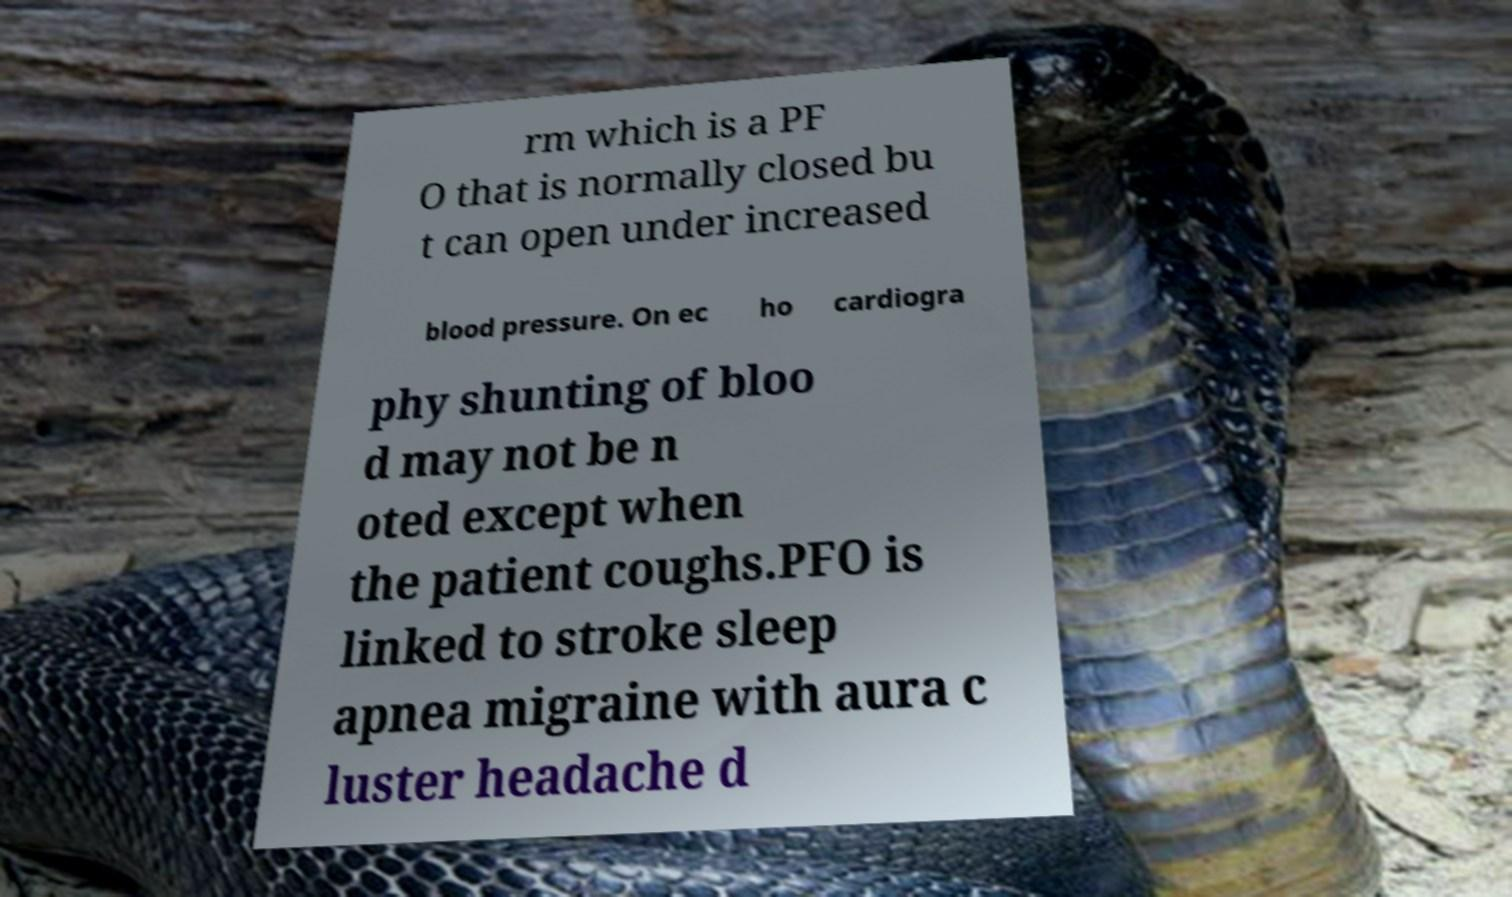Please read and relay the text visible in this image. What does it say? rm which is a PF O that is normally closed bu t can open under increased blood pressure. On ec ho cardiogra phy shunting of bloo d may not be n oted except when the patient coughs.PFO is linked to stroke sleep apnea migraine with aura c luster headache d 